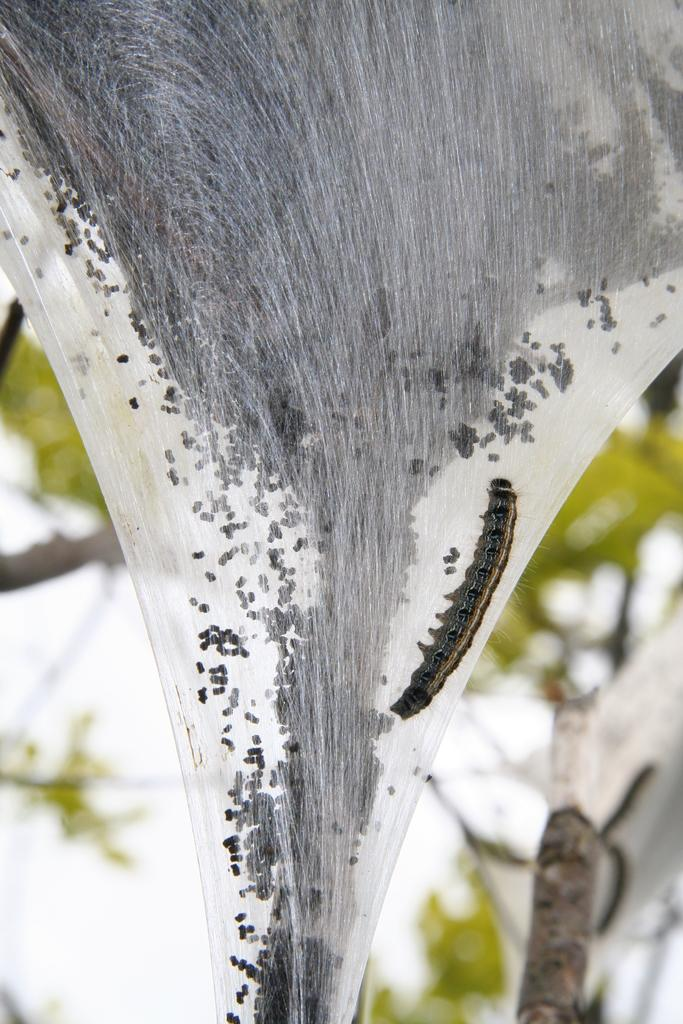What is the main subject of the image? The main subject of the image is a tent caterpillar. Can you describe the background of the image? The background of the image is blurred. What type of rifle can be seen in the image? There is no rifle present in the image; it features a tent caterpillar. How many keys are visible in the image? There are no keys visible in the image; it features a tent caterpillar. 